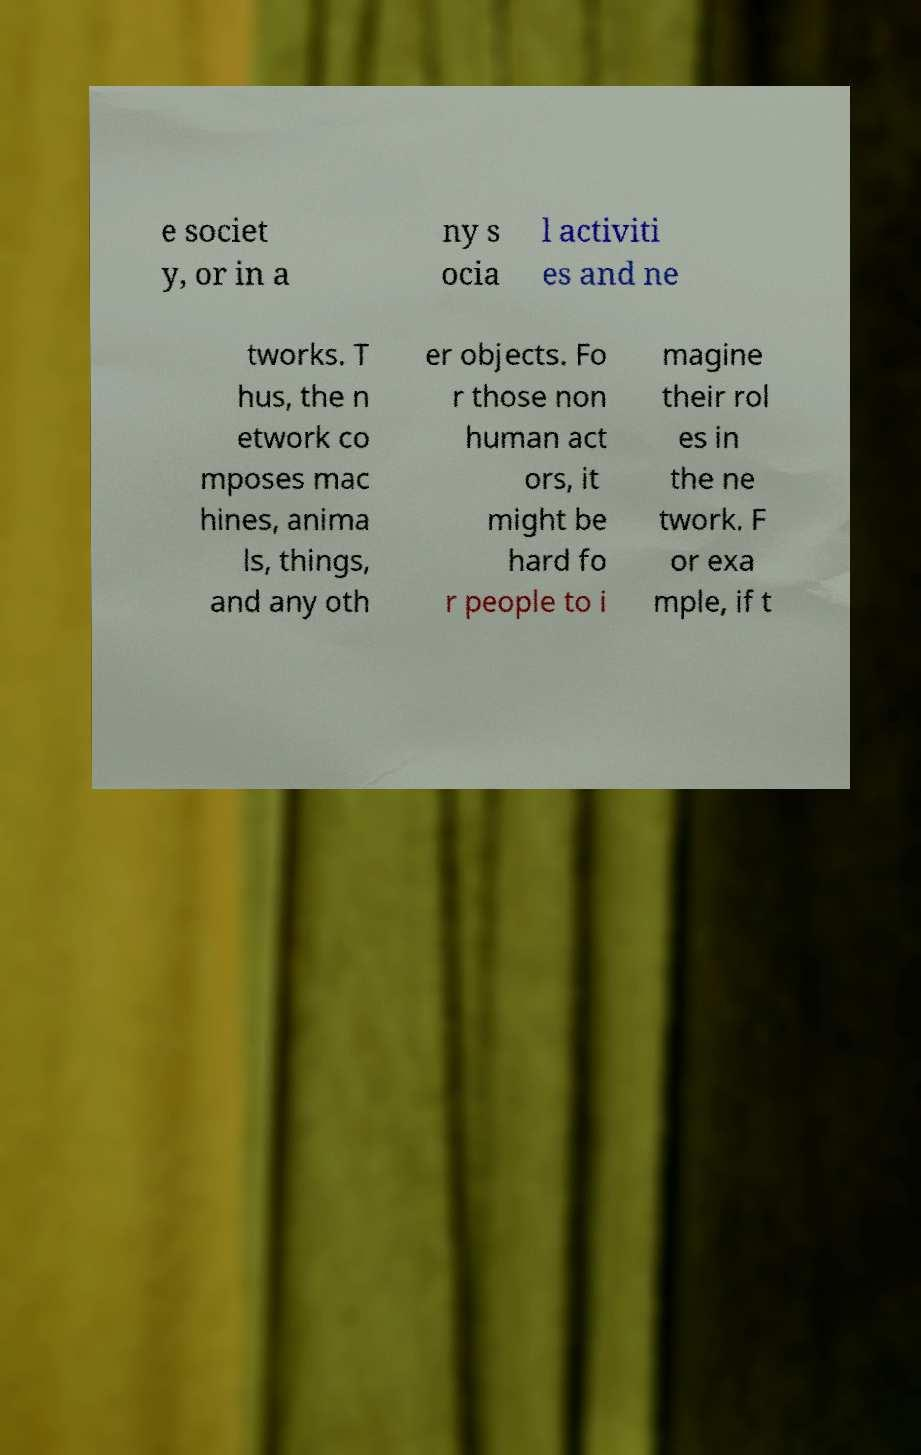Please read and relay the text visible in this image. What does it say? e societ y, or in a ny s ocia l activiti es and ne tworks. T hus, the n etwork co mposes mac hines, anima ls, things, and any oth er objects. Fo r those non human act ors, it might be hard fo r people to i magine their rol es in the ne twork. F or exa mple, if t 